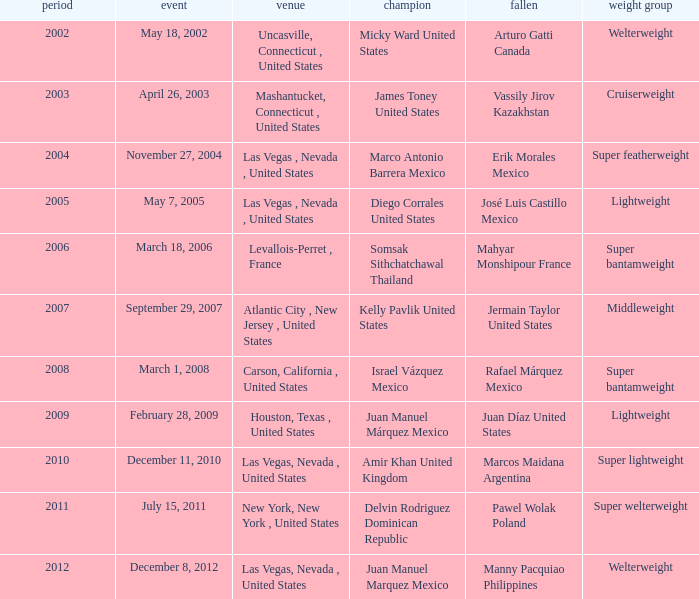How many years were lightweight class on february 28, 2009? 1.0. 